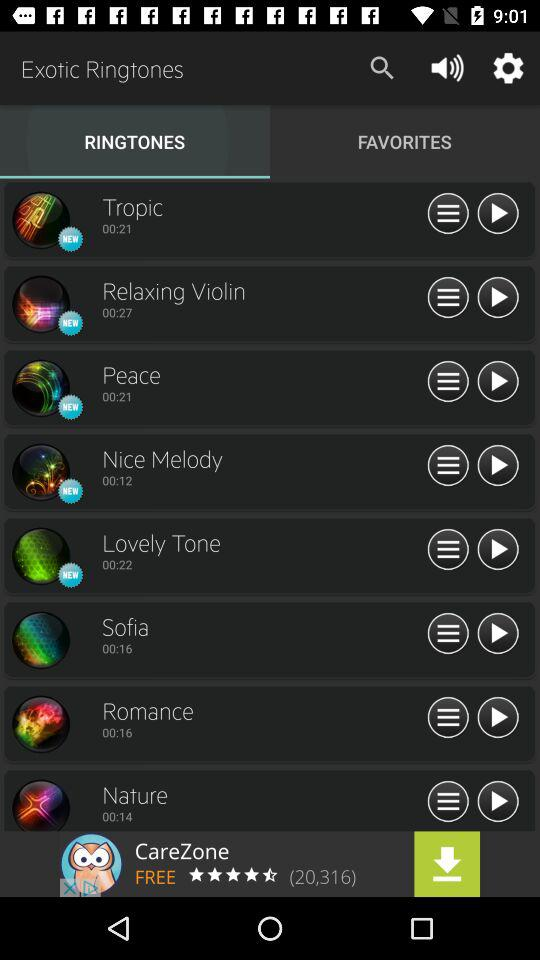What tab am I on? You are on the "RINGTONES" tab. 